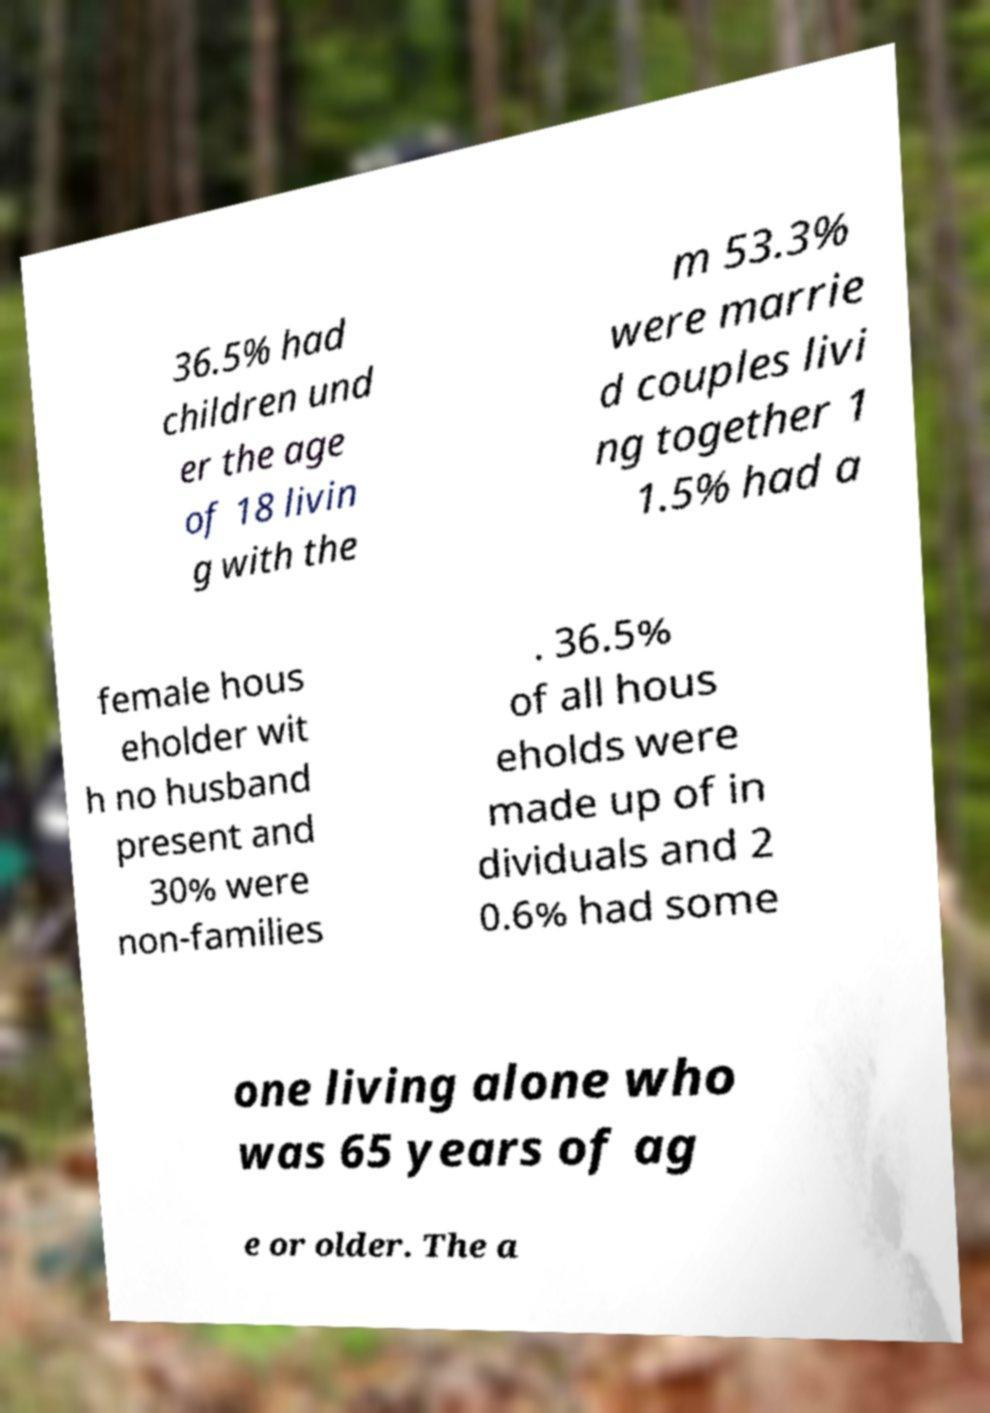Could you extract and type out the text from this image? 36.5% had children und er the age of 18 livin g with the m 53.3% were marrie d couples livi ng together 1 1.5% had a female hous eholder wit h no husband present and 30% were non-families . 36.5% of all hous eholds were made up of in dividuals and 2 0.6% had some one living alone who was 65 years of ag e or older. The a 